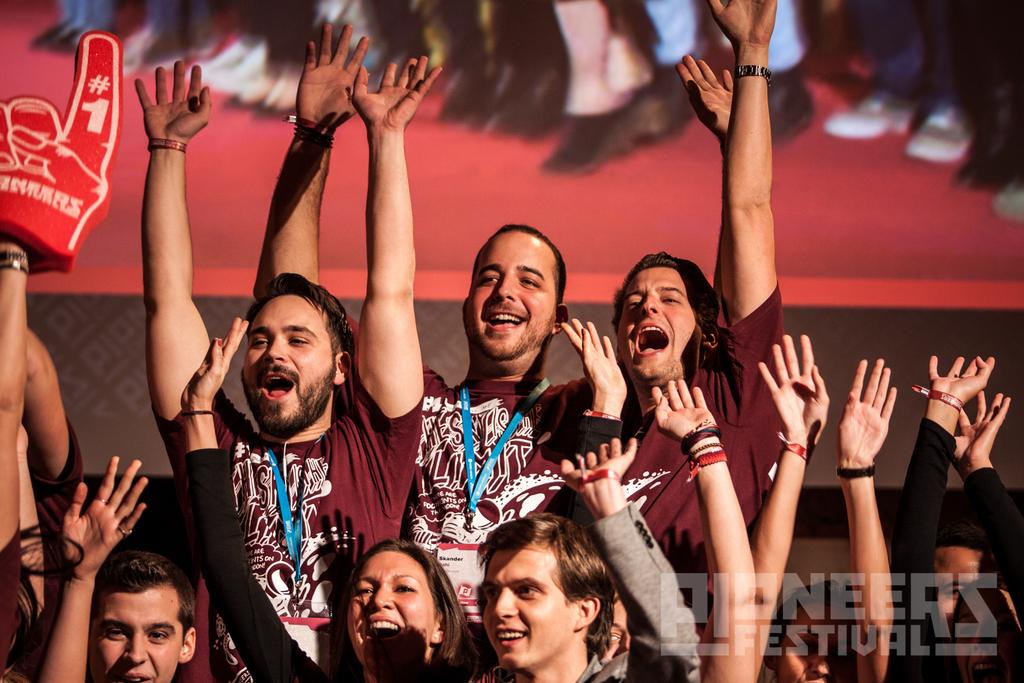What is happening with the people in the image? The people standing in the image have raised their hands up. Can you describe the background color in the image? The background of the image is red in color. Can you see a comb being used by anyone in the image? There is no comb visible in the image. What time of day is it in the image? The provided facts do not mention the time of day, so it cannot be determined from the image. 